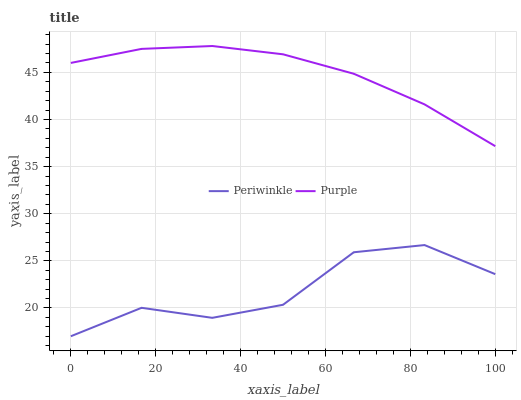Does Periwinkle have the minimum area under the curve?
Answer yes or no. Yes. Does Purple have the maximum area under the curve?
Answer yes or no. Yes. Does Periwinkle have the maximum area under the curve?
Answer yes or no. No. Is Purple the smoothest?
Answer yes or no. Yes. Is Periwinkle the roughest?
Answer yes or no. Yes. Is Periwinkle the smoothest?
Answer yes or no. No. Does Periwinkle have the lowest value?
Answer yes or no. Yes. Does Purple have the highest value?
Answer yes or no. Yes. Does Periwinkle have the highest value?
Answer yes or no. No. Is Periwinkle less than Purple?
Answer yes or no. Yes. Is Purple greater than Periwinkle?
Answer yes or no. Yes. Does Periwinkle intersect Purple?
Answer yes or no. No. 